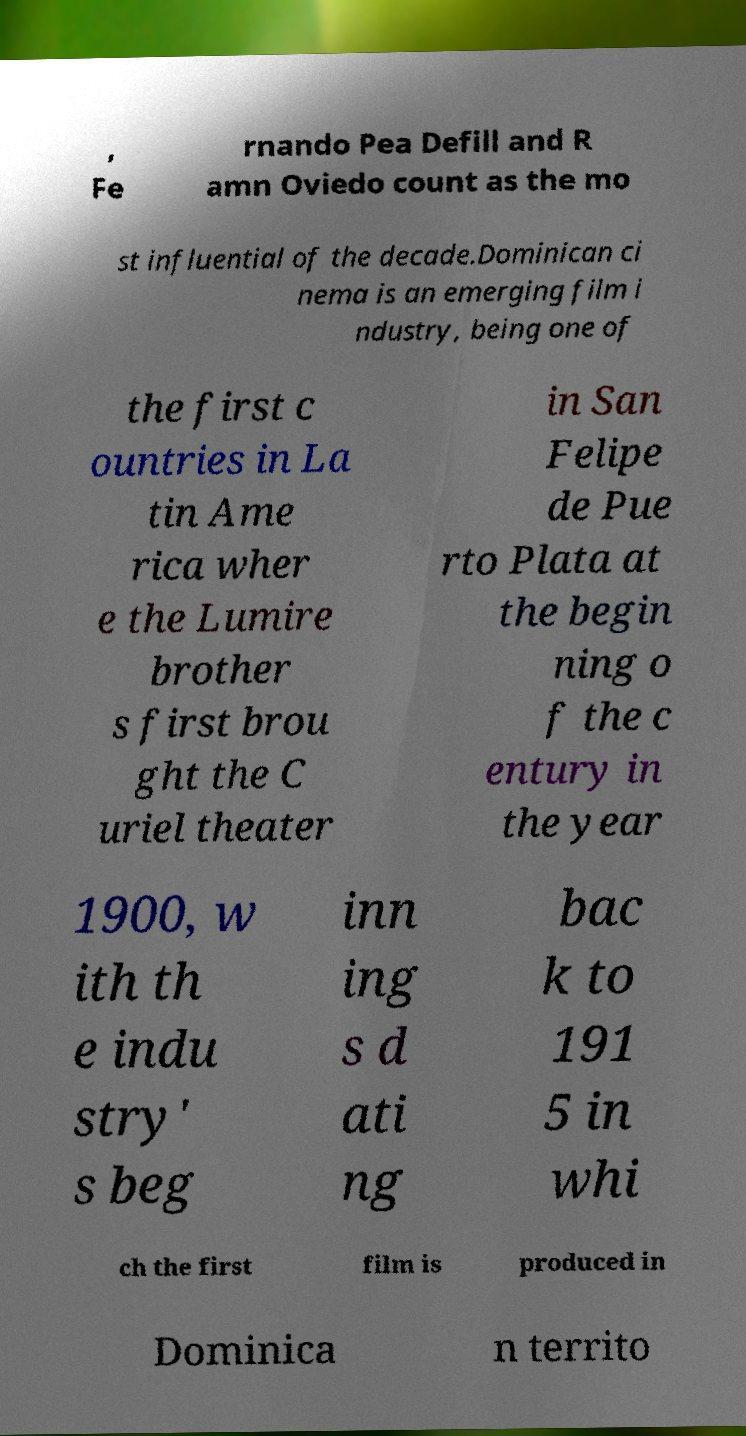Can you accurately transcribe the text from the provided image for me? , Fe rnando Pea Defill and R amn Oviedo count as the mo st influential of the decade.Dominican ci nema is an emerging film i ndustry, being one of the first c ountries in La tin Ame rica wher e the Lumire brother s first brou ght the C uriel theater in San Felipe de Pue rto Plata at the begin ning o f the c entury in the year 1900, w ith th e indu stry' s beg inn ing s d ati ng bac k to 191 5 in whi ch the first film is produced in Dominica n territo 